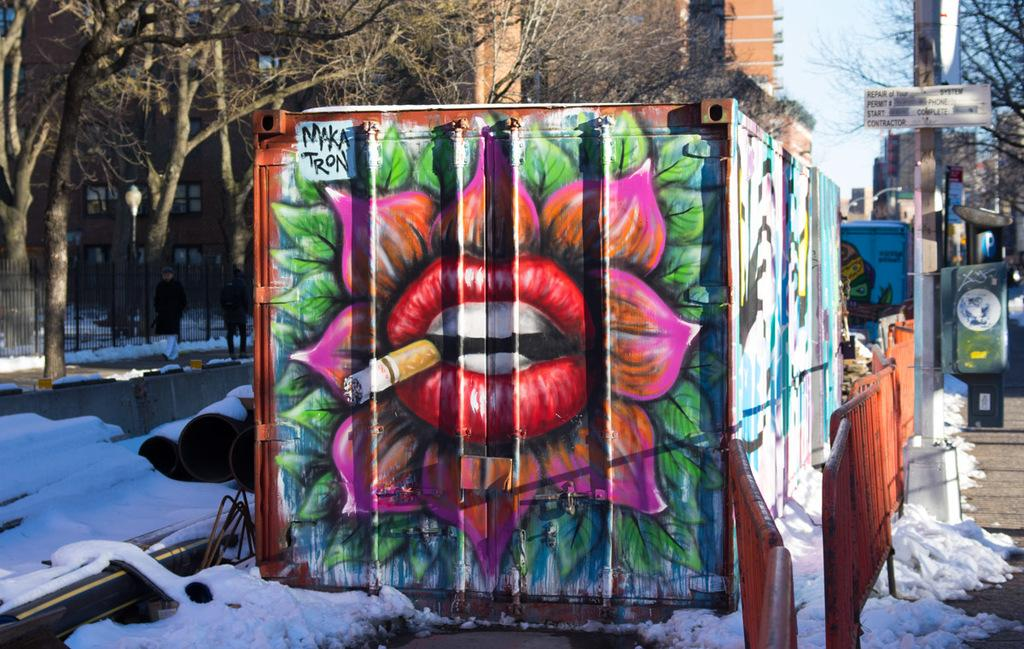What is the medium of the image? The image appears to be a painting on a container. What is depicted in the foreground of the image? There is snow and barricades in the foreground. What can be seen in the background of the image? There are trees, buildings, poles, and the sky visible in the background. What advice does the face in the image give to the viewer? There is no face present in the image, so no advice can be given. 